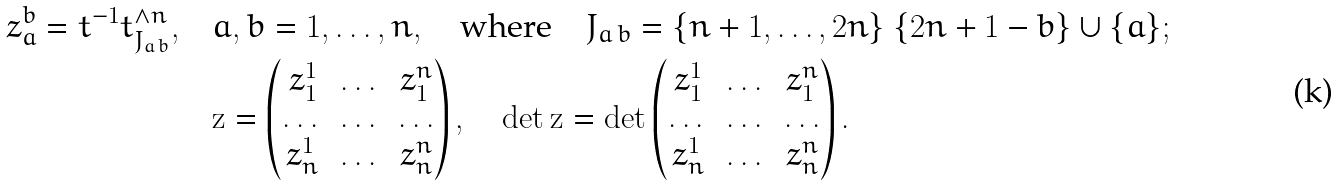<formula> <loc_0><loc_0><loc_500><loc_500>z _ { a } ^ { b } = t ^ { - 1 } t ^ { \wedge n } _ { J _ { a \, b } } , \quad & a , b = 1 , \dots , n , \quad \text {where} \quad J _ { a \, b } = \{ n + 1 , \dots , 2 n \} \ \{ 2 n + 1 - b \} \cup \{ a \} ; \\ & \mathbf z = \begin{pmatrix} z _ { 1 } ^ { 1 } & \dots & z _ { 1 } ^ { n } \\ \dots & \dots & \dots \\ z _ { n } ^ { 1 } & \dots & z _ { n } ^ { n } \end{pmatrix} , \quad \det \mathbf z = \det \begin{pmatrix} z _ { 1 } ^ { 1 } & \dots & z _ { 1 } ^ { n } \\ \dots & \dots & \dots \\ z _ { n } ^ { 1 } & \dots & z _ { n } ^ { n } \end{pmatrix} .</formula> 